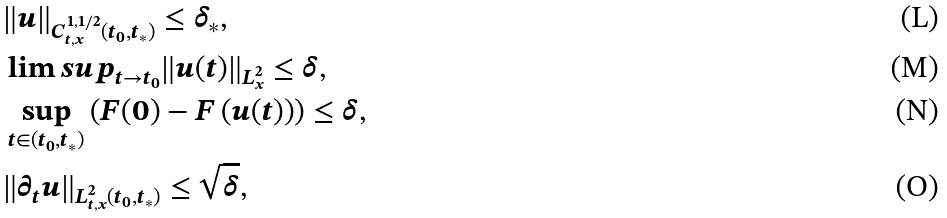Convert formula to latex. <formula><loc_0><loc_0><loc_500><loc_500>& \| u \| _ { C ^ { 1 , 1 / 2 } _ { t , x } ( t _ { 0 } , t _ { * } ) } \leq \delta _ { * } , \\ & \lim s u p _ { t \to t _ { 0 } } \| u ( t ) \| _ { L ^ { 2 } _ { x } } \leq \delta , \\ & \sup _ { t \in ( t _ { 0 } , t _ { * } ) } \left ( { F } ( 0 ) - { F } \left ( u ( t ) \right ) \right ) \leq \delta , \\ & \| \partial _ { t } u \| _ { L ^ { 2 } _ { t , x } ( t _ { 0 } , t _ { * } ) } \leq \sqrt { \delta } ,</formula> 